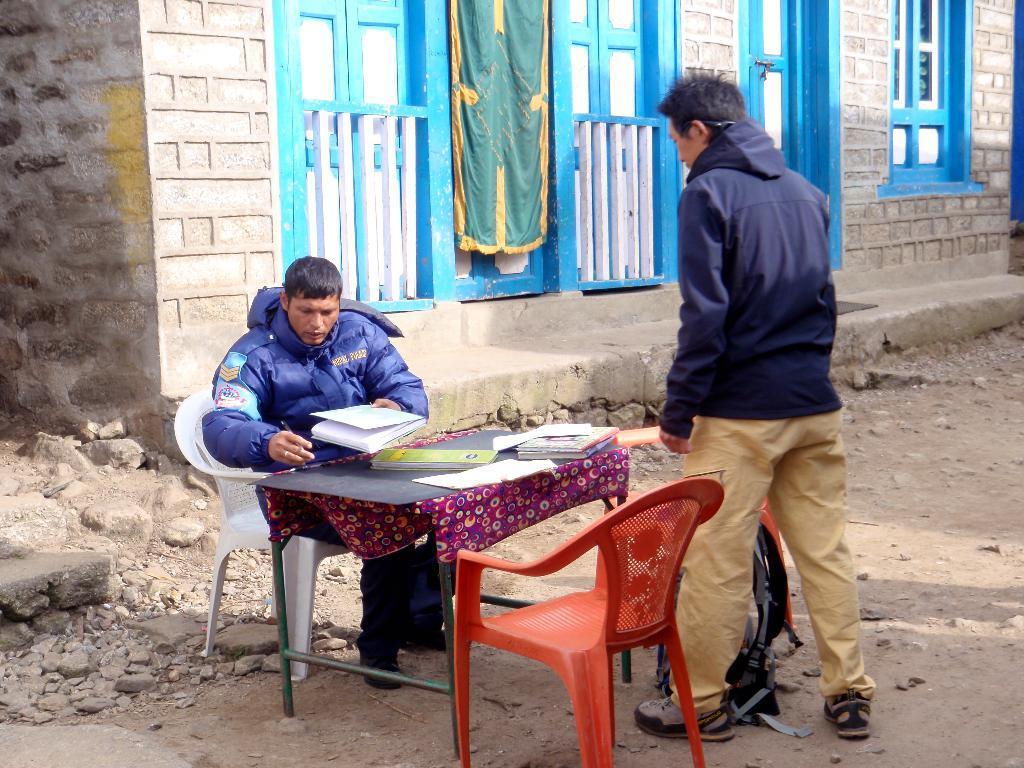In one or two sentences, can you explain what this image depicts? The person wearing blue jacket is sitting in a chair and there is a table in front of him which has some books on it and there is also another person standing in front of him. 